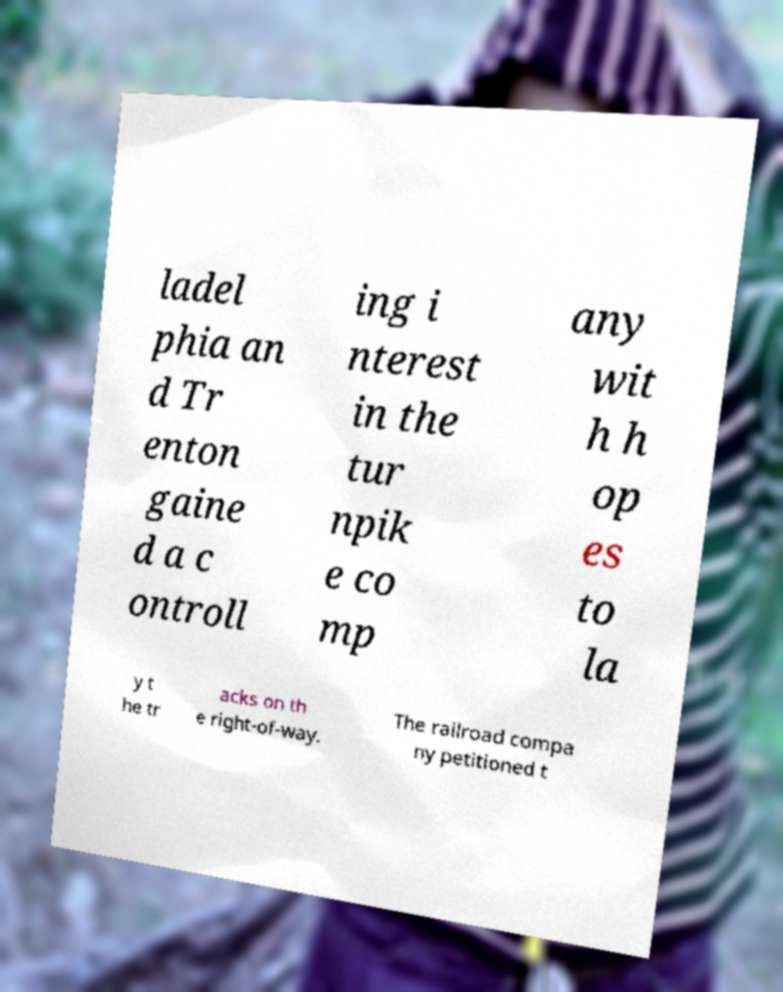Please identify and transcribe the text found in this image. ladel phia an d Tr enton gaine d a c ontroll ing i nterest in the tur npik e co mp any wit h h op es to la y t he tr acks on th e right-of-way. The railroad compa ny petitioned t 